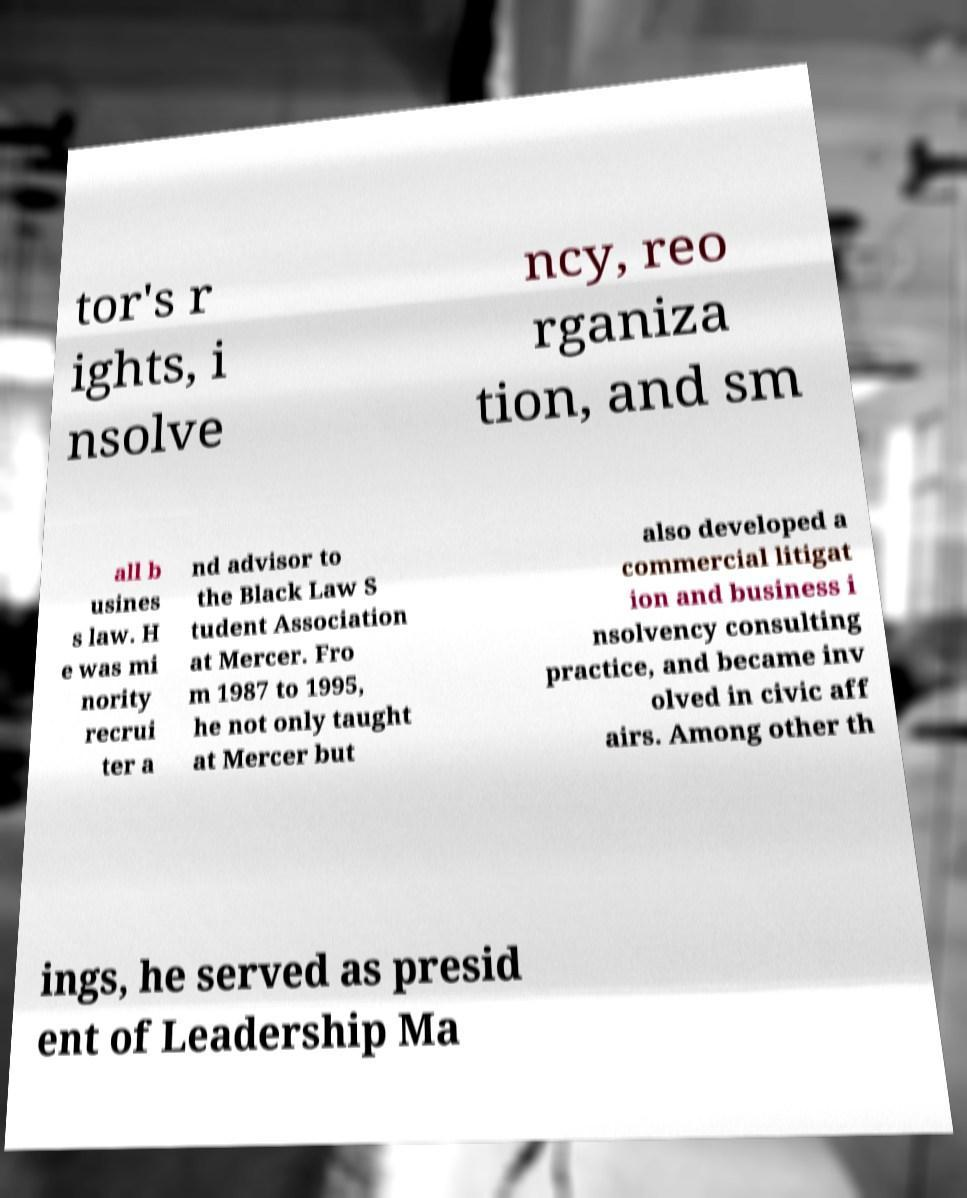There's text embedded in this image that I need extracted. Can you transcribe it verbatim? tor's r ights, i nsolve ncy, reo rganiza tion, and sm all b usines s law. H e was mi nority recrui ter a nd advisor to the Black Law S tudent Association at Mercer. Fro m 1987 to 1995, he not only taught at Mercer but also developed a commercial litigat ion and business i nsolvency consulting practice, and became inv olved in civic aff airs. Among other th ings, he served as presid ent of Leadership Ma 